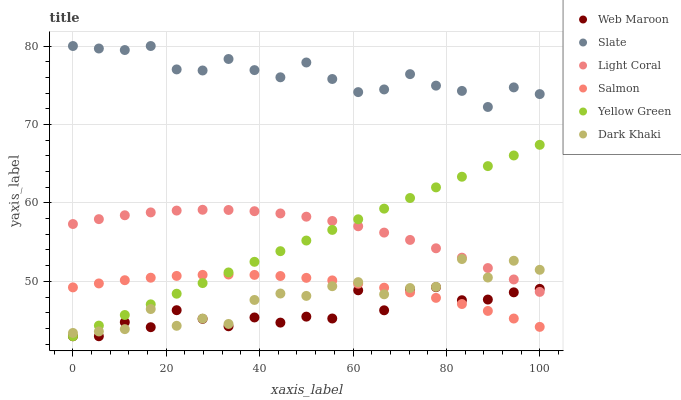Does Web Maroon have the minimum area under the curve?
Answer yes or no. Yes. Does Slate have the maximum area under the curve?
Answer yes or no. Yes. Does Yellow Green have the minimum area under the curve?
Answer yes or no. No. Does Yellow Green have the maximum area under the curve?
Answer yes or no. No. Is Yellow Green the smoothest?
Answer yes or no. Yes. Is Dark Khaki the roughest?
Answer yes or no. Yes. Is Web Maroon the smoothest?
Answer yes or no. No. Is Web Maroon the roughest?
Answer yes or no. No. Does Yellow Green have the lowest value?
Answer yes or no. Yes. Does Slate have the lowest value?
Answer yes or no. No. Does Slate have the highest value?
Answer yes or no. Yes. Does Yellow Green have the highest value?
Answer yes or no. No. Is Light Coral less than Slate?
Answer yes or no. Yes. Is Light Coral greater than Salmon?
Answer yes or no. Yes. Does Salmon intersect Dark Khaki?
Answer yes or no. Yes. Is Salmon less than Dark Khaki?
Answer yes or no. No. Is Salmon greater than Dark Khaki?
Answer yes or no. No. Does Light Coral intersect Slate?
Answer yes or no. No. 